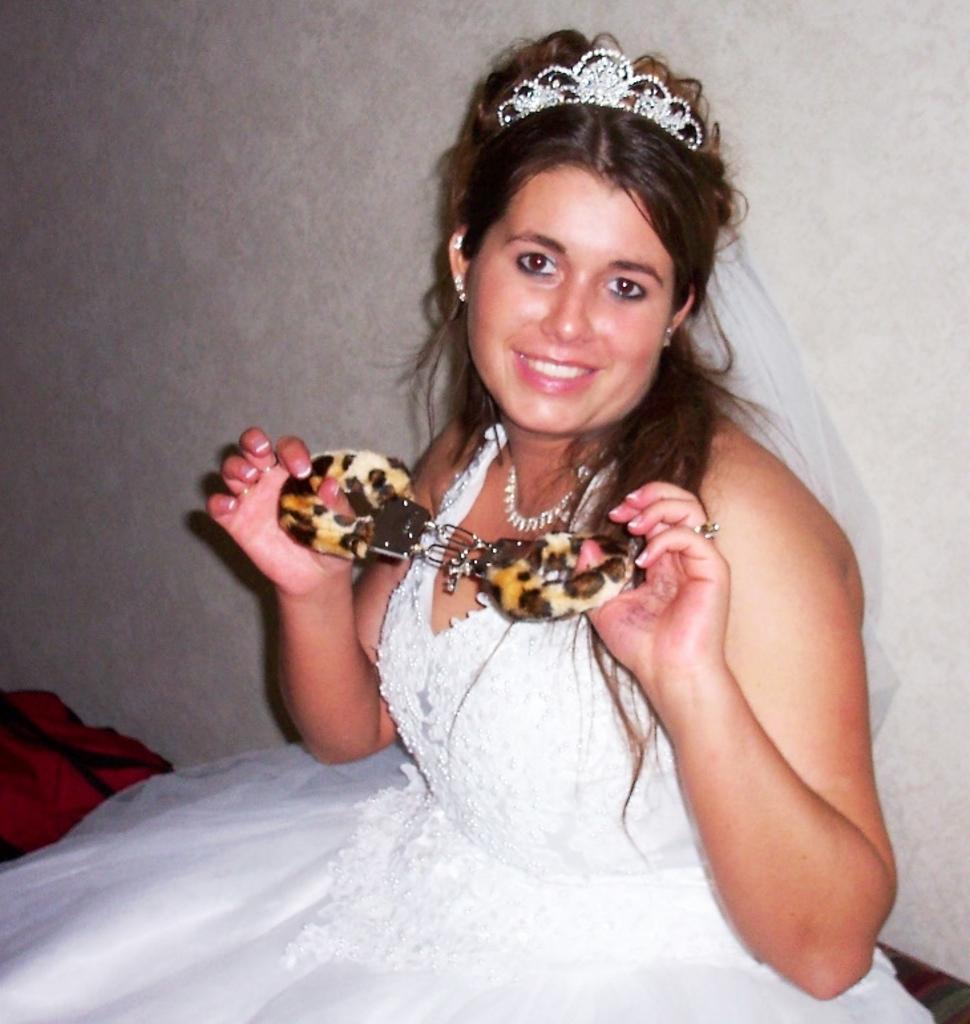In one or two sentences, can you explain what this image depicts? In the picture we can see a woman sitting on the floor and smiling, she is in a white dress and crown and holding something in her hand and stretching and behind her we can see a wall. 